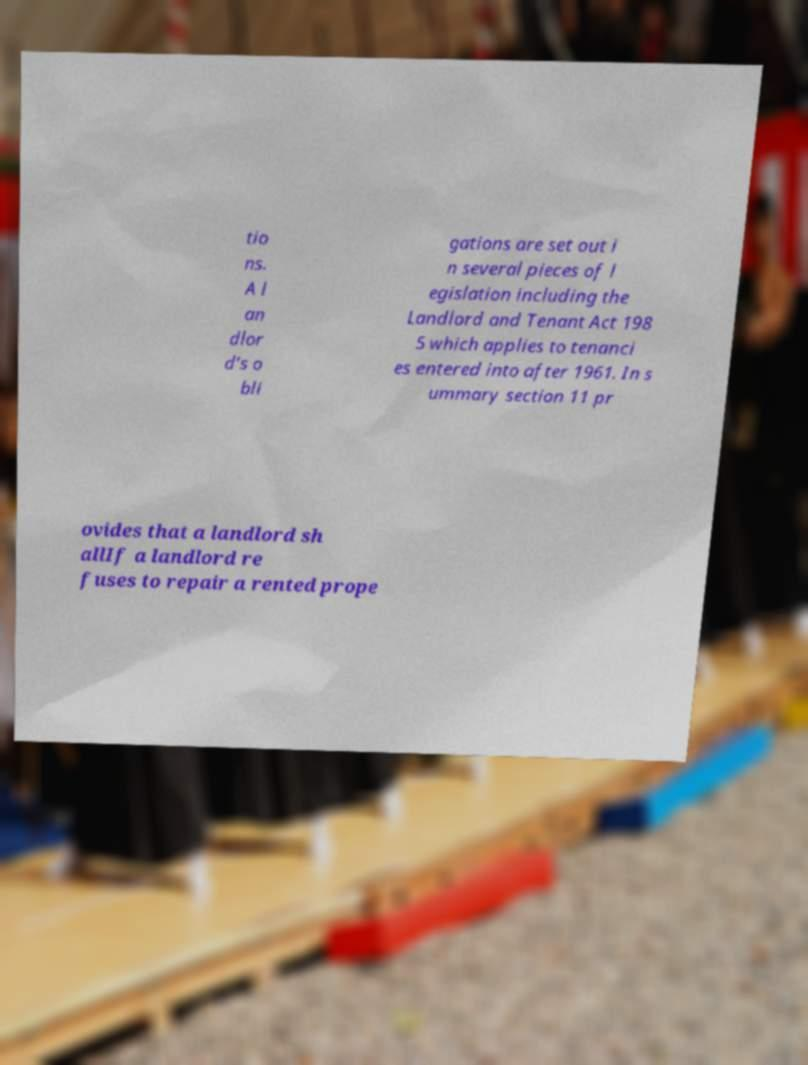Please read and relay the text visible in this image. What does it say? tio ns. A l an dlor d’s o bli gations are set out i n several pieces of l egislation including the Landlord and Tenant Act 198 5 which applies to tenanci es entered into after 1961. In s ummary section 11 pr ovides that a landlord sh allIf a landlord re fuses to repair a rented prope 